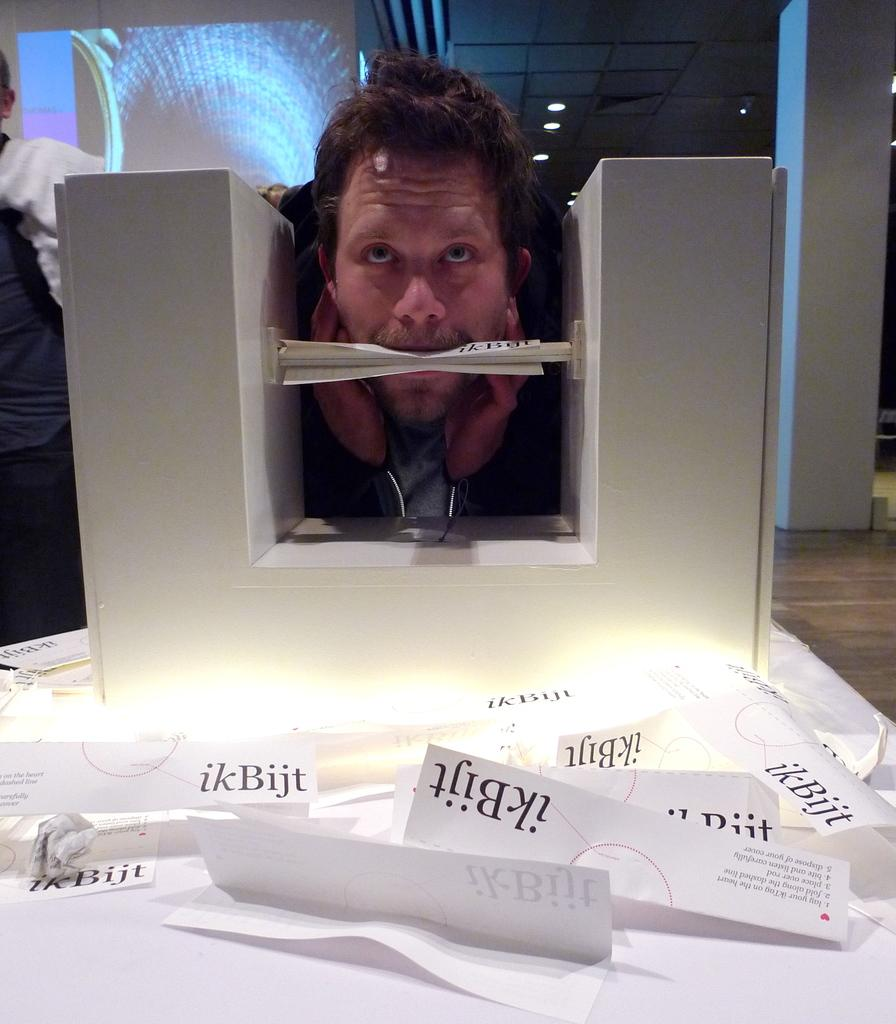Provide a one-sentence caption for the provided image. A man is biting a white paper that says ikBijt. 